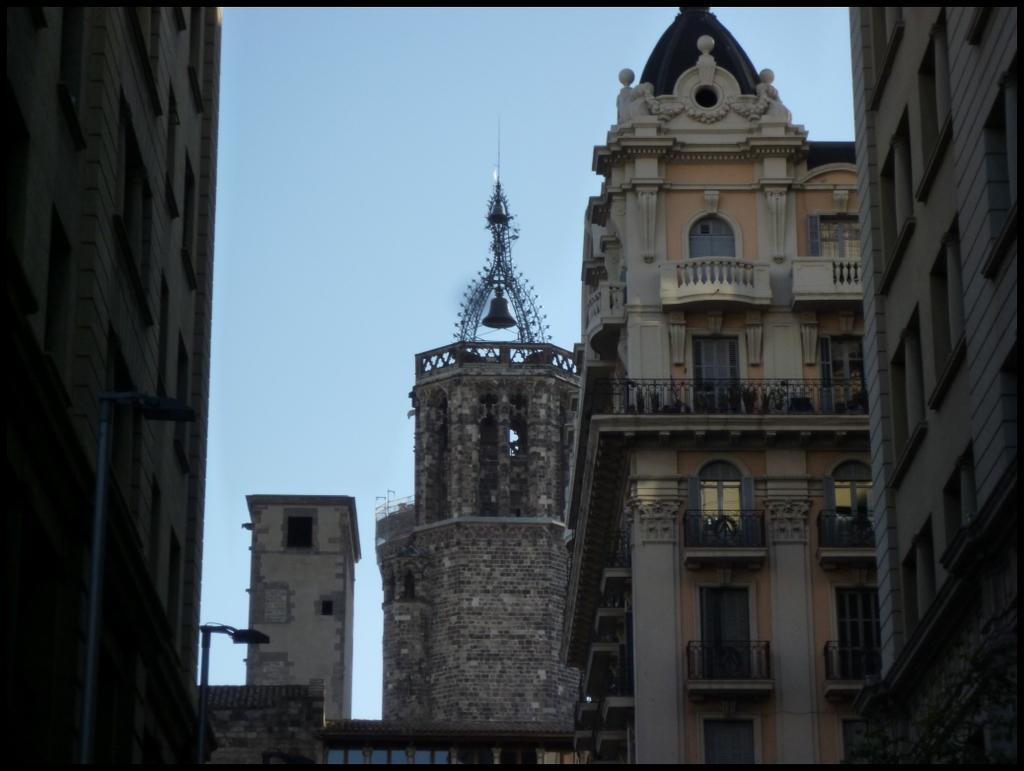What can be seen in the image? There are many buildings in the image. How are the buildings arranged in the image? The buildings are beside each other. What features can be observed on the buildings? The buildings have a lot of windows and doors. What is visible in the background of the image? The sky is visible in the background of the image. What type of volleyball game is being played in the image? There is no volleyball game present in the image; it features many buildings with windows and doors. What emotion is being expressed by the buildings in the image? Buildings do not express emotions, so this question cannot be answered. 